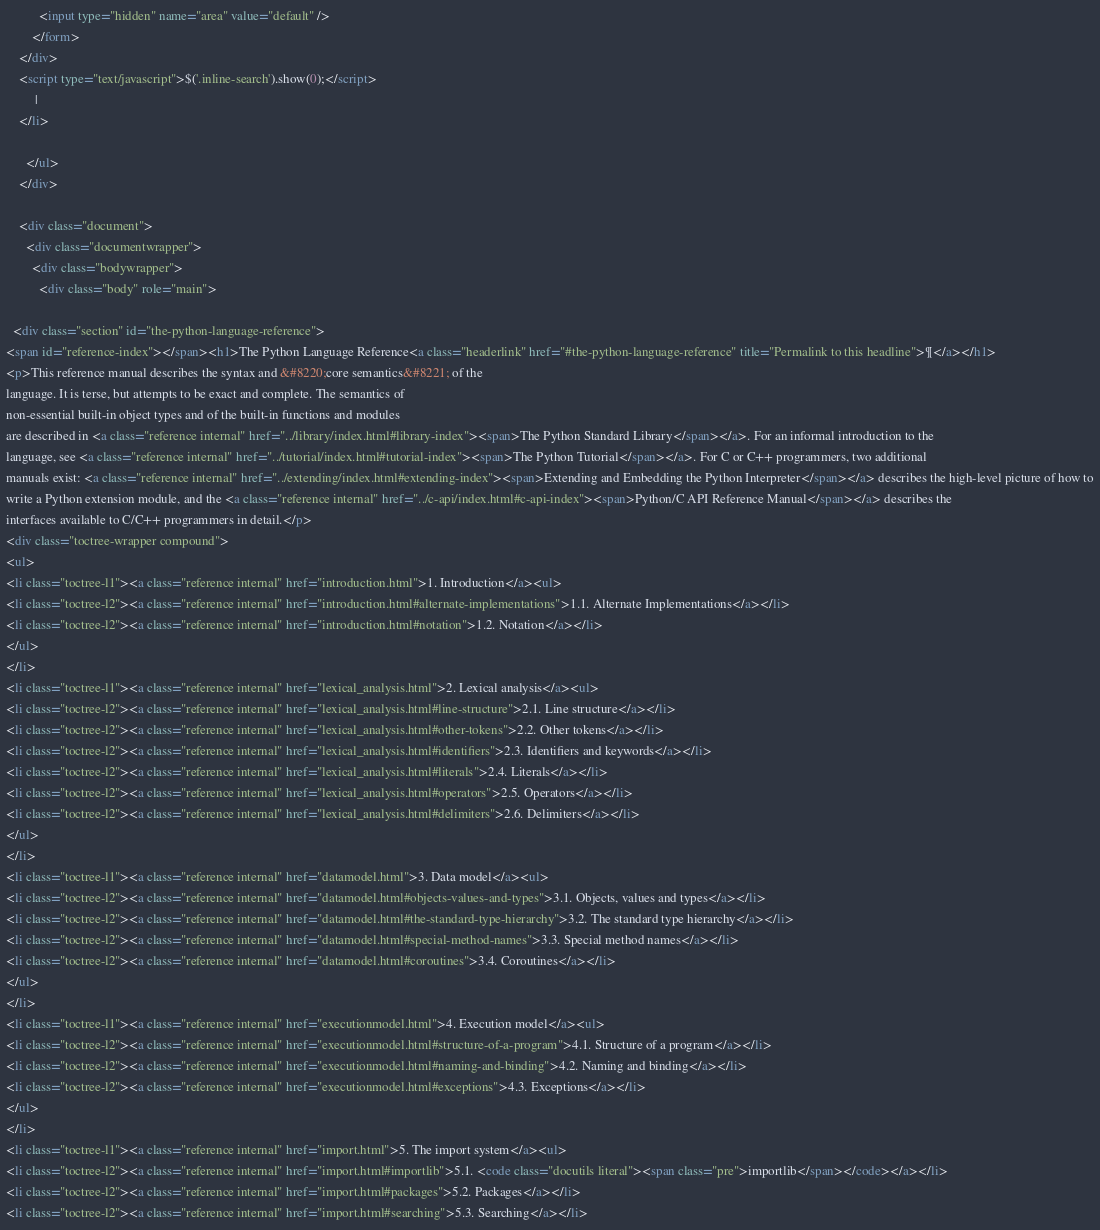Convert code to text. <code><loc_0><loc_0><loc_500><loc_500><_HTML_>          <input type="hidden" name="area" value="default" />
        </form>
    </div>
    <script type="text/javascript">$('.inline-search').show(0);</script>
         |
    </li>

      </ul>
    </div>    

    <div class="document">
      <div class="documentwrapper">
        <div class="bodywrapper">
          <div class="body" role="main">
            
  <div class="section" id="the-python-language-reference">
<span id="reference-index"></span><h1>The Python Language Reference<a class="headerlink" href="#the-python-language-reference" title="Permalink to this headline">¶</a></h1>
<p>This reference manual describes the syntax and &#8220;core semantics&#8221; of the
language. It is terse, but attempts to be exact and complete. The semantics of
non-essential built-in object types and of the built-in functions and modules
are described in <a class="reference internal" href="../library/index.html#library-index"><span>The Python Standard Library</span></a>. For an informal introduction to the
language, see <a class="reference internal" href="../tutorial/index.html#tutorial-index"><span>The Python Tutorial</span></a>. For C or C++ programmers, two additional
manuals exist: <a class="reference internal" href="../extending/index.html#extending-index"><span>Extending and Embedding the Python Interpreter</span></a> describes the high-level picture of how to
write a Python extension module, and the <a class="reference internal" href="../c-api/index.html#c-api-index"><span>Python/C API Reference Manual</span></a> describes the
interfaces available to C/C++ programmers in detail.</p>
<div class="toctree-wrapper compound">
<ul>
<li class="toctree-l1"><a class="reference internal" href="introduction.html">1. Introduction</a><ul>
<li class="toctree-l2"><a class="reference internal" href="introduction.html#alternate-implementations">1.1. Alternate Implementations</a></li>
<li class="toctree-l2"><a class="reference internal" href="introduction.html#notation">1.2. Notation</a></li>
</ul>
</li>
<li class="toctree-l1"><a class="reference internal" href="lexical_analysis.html">2. Lexical analysis</a><ul>
<li class="toctree-l2"><a class="reference internal" href="lexical_analysis.html#line-structure">2.1. Line structure</a></li>
<li class="toctree-l2"><a class="reference internal" href="lexical_analysis.html#other-tokens">2.2. Other tokens</a></li>
<li class="toctree-l2"><a class="reference internal" href="lexical_analysis.html#identifiers">2.3. Identifiers and keywords</a></li>
<li class="toctree-l2"><a class="reference internal" href="lexical_analysis.html#literals">2.4. Literals</a></li>
<li class="toctree-l2"><a class="reference internal" href="lexical_analysis.html#operators">2.5. Operators</a></li>
<li class="toctree-l2"><a class="reference internal" href="lexical_analysis.html#delimiters">2.6. Delimiters</a></li>
</ul>
</li>
<li class="toctree-l1"><a class="reference internal" href="datamodel.html">3. Data model</a><ul>
<li class="toctree-l2"><a class="reference internal" href="datamodel.html#objects-values-and-types">3.1. Objects, values and types</a></li>
<li class="toctree-l2"><a class="reference internal" href="datamodel.html#the-standard-type-hierarchy">3.2. The standard type hierarchy</a></li>
<li class="toctree-l2"><a class="reference internal" href="datamodel.html#special-method-names">3.3. Special method names</a></li>
<li class="toctree-l2"><a class="reference internal" href="datamodel.html#coroutines">3.4. Coroutines</a></li>
</ul>
</li>
<li class="toctree-l1"><a class="reference internal" href="executionmodel.html">4. Execution model</a><ul>
<li class="toctree-l2"><a class="reference internal" href="executionmodel.html#structure-of-a-program">4.1. Structure of a program</a></li>
<li class="toctree-l2"><a class="reference internal" href="executionmodel.html#naming-and-binding">4.2. Naming and binding</a></li>
<li class="toctree-l2"><a class="reference internal" href="executionmodel.html#exceptions">4.3. Exceptions</a></li>
</ul>
</li>
<li class="toctree-l1"><a class="reference internal" href="import.html">5. The import system</a><ul>
<li class="toctree-l2"><a class="reference internal" href="import.html#importlib">5.1. <code class="docutils literal"><span class="pre">importlib</span></code></a></li>
<li class="toctree-l2"><a class="reference internal" href="import.html#packages">5.2. Packages</a></li>
<li class="toctree-l2"><a class="reference internal" href="import.html#searching">5.3. Searching</a></li></code> 